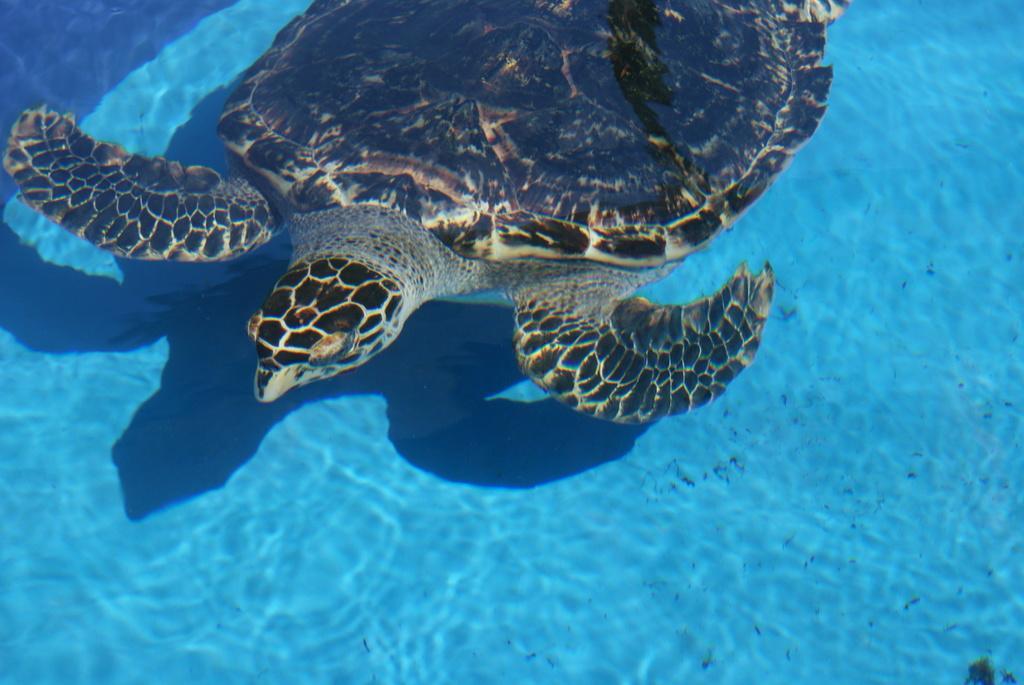Please provide a concise description of this image. In this image we can see a tortoise in the water. 